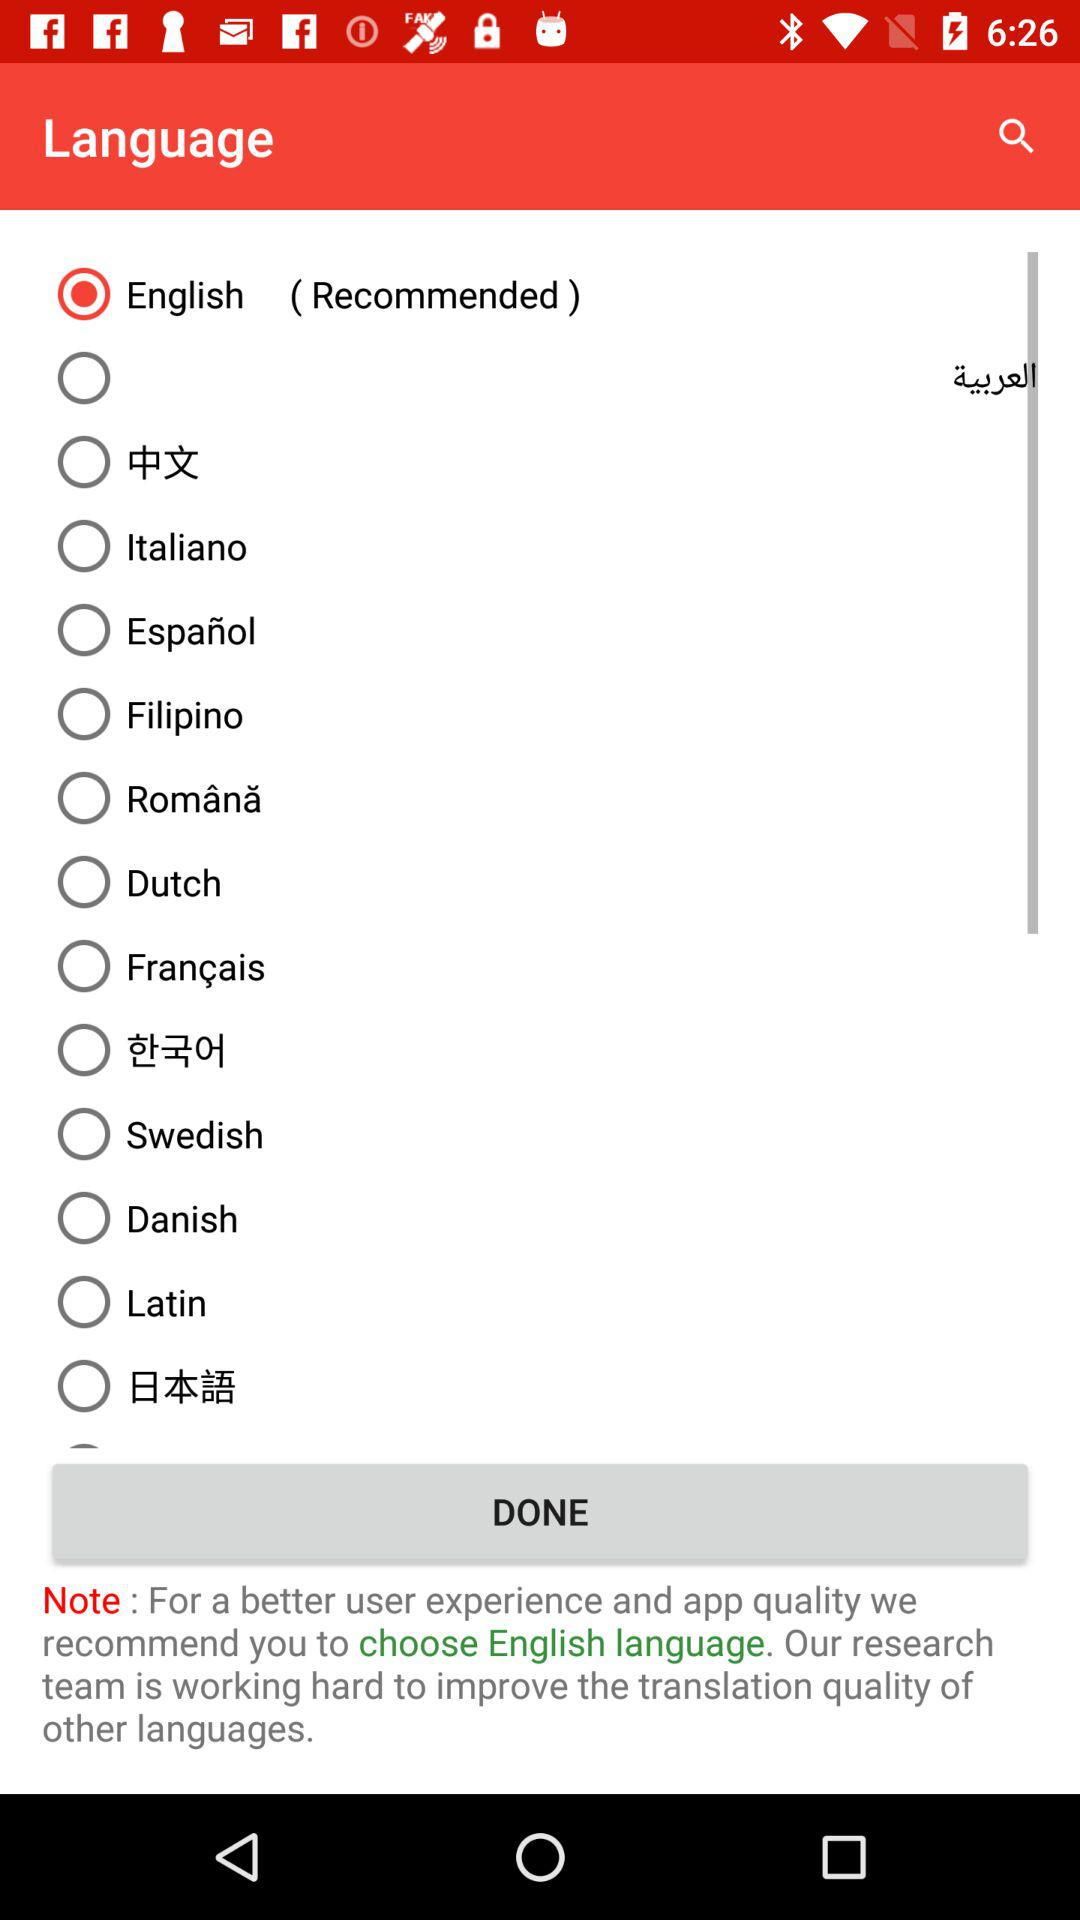Which language is recommended by the app?
Answer the question using a single word or phrase. English 